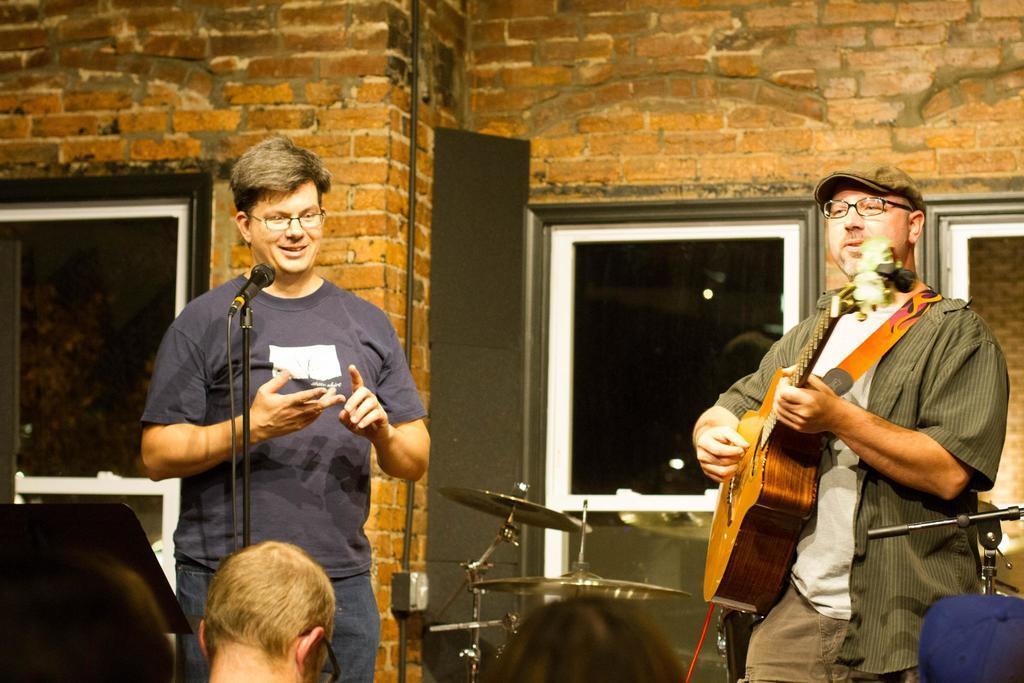Please provide a concise description of this image. Here we can see a man standing and smiling, and in front here is the microphone, and here a person is standing and holding a guitar in his hands, and here are the drums, and here is the wall made of bricks and here is the window. 